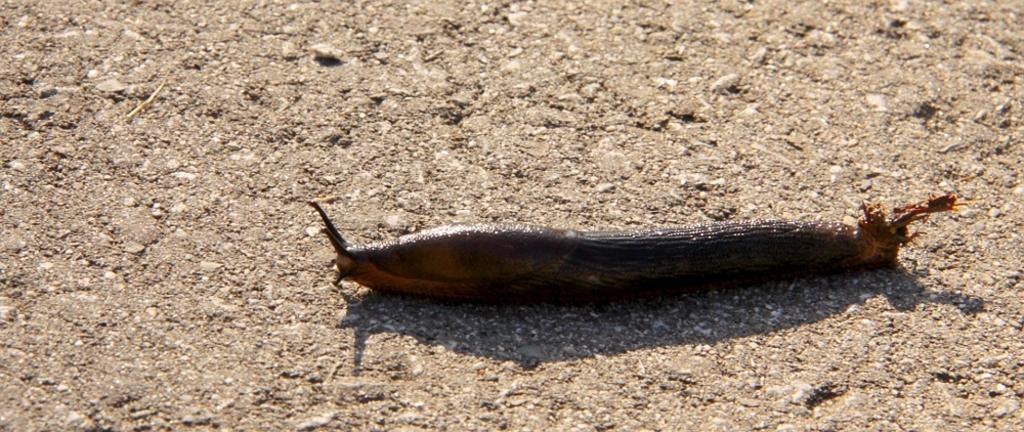Could you give a brief overview of what you see in this image? In this picture we can see a slug on the ground. 